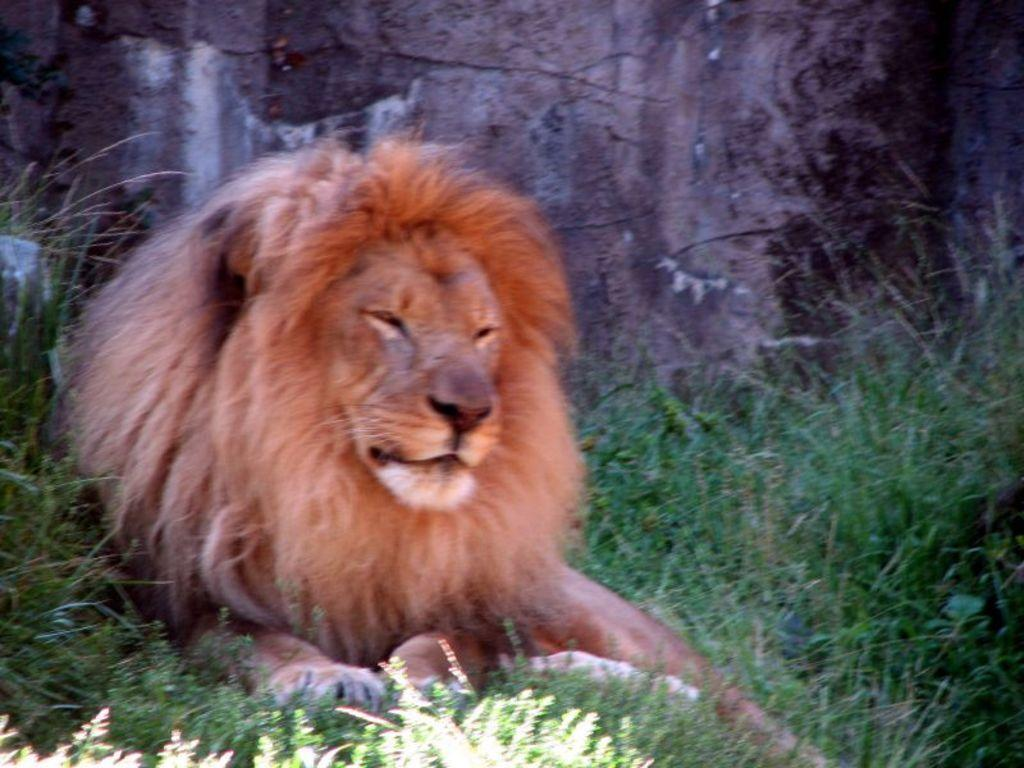What animal is in the image? There is a lion in the image. What is the lion doing in the image? The lion is sitting. What can be seen on the ground in the image? The ground is covered in greenery. What type of hammer is the lion holding in the image? There is no hammer present in the image; the lion is simply sitting. 